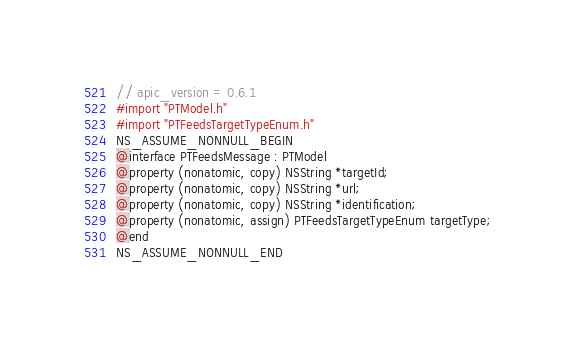<code> <loc_0><loc_0><loc_500><loc_500><_C_>// apic_version = 0.6.1
#import "PTModel.h"
#import "PTFeedsTargetTypeEnum.h"
NS_ASSUME_NONNULL_BEGIN
@interface PTFeedsMessage : PTModel
@property (nonatomic, copy) NSString *targetId;
@property (nonatomic, copy) NSString *url;
@property (nonatomic, copy) NSString *identification;
@property (nonatomic, assign) PTFeedsTargetTypeEnum targetType;
@end
NS_ASSUME_NONNULL_END
</code> 